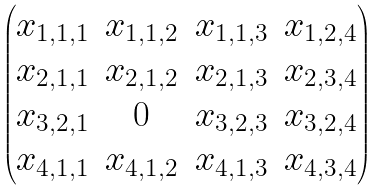Convert formula to latex. <formula><loc_0><loc_0><loc_500><loc_500>\begin{pmatrix} x _ { 1 , 1 , 1 } & x _ { 1 , 1 , 2 } & x _ { 1 , 1 , 3 } & x _ { 1 , 2 , 4 } \\ x _ { 2 , 1 , 1 } & x _ { 2 , 1 , 2 } & x _ { 2 , 1 , 3 } & x _ { 2 , 3 , 4 } \\ x _ { 3 , 2 , 1 } & 0 & x _ { 3 , 2 , 3 } & x _ { 3 , 2 , 4 } \\ x _ { 4 , 1 , 1 } & x _ { 4 , 1 , 2 } & x _ { 4 , 1 , 3 } & x _ { 4 , 3 , 4 } \end{pmatrix}</formula> 